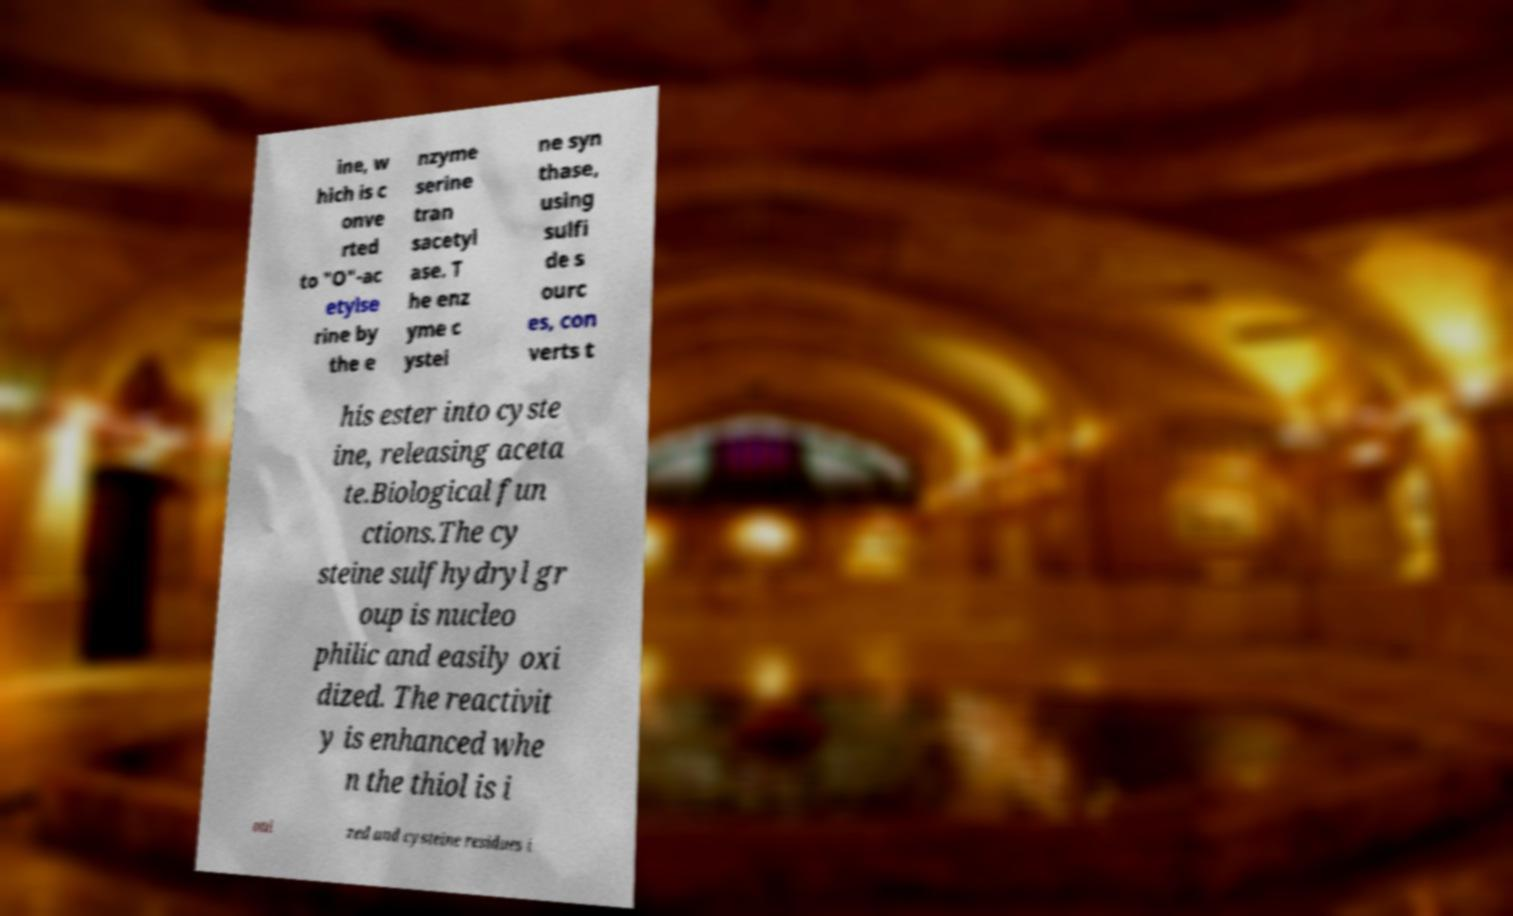What messages or text are displayed in this image? I need them in a readable, typed format. ine, w hich is c onve rted to "O"-ac etylse rine by the e nzyme serine tran sacetyl ase. T he enz yme c ystei ne syn thase, using sulfi de s ourc es, con verts t his ester into cyste ine, releasing aceta te.Biological fun ctions.The cy steine sulfhydryl gr oup is nucleo philic and easily oxi dized. The reactivit y is enhanced whe n the thiol is i oni zed and cysteine residues i 